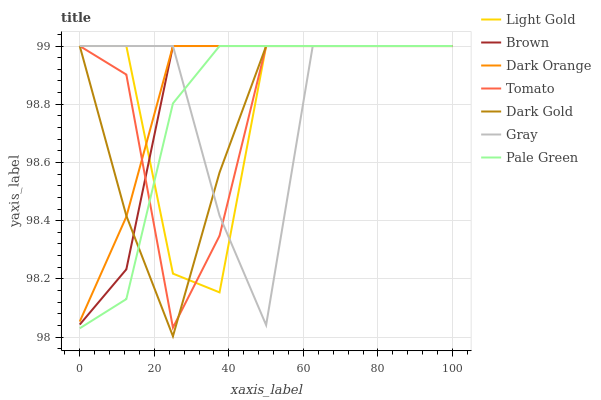Does Dark Gold have the minimum area under the curve?
Answer yes or no. Yes. Does Dark Orange have the maximum area under the curve?
Answer yes or no. Yes. Does Brown have the minimum area under the curve?
Answer yes or no. No. Does Brown have the maximum area under the curve?
Answer yes or no. No. Is Dark Orange the smoothest?
Answer yes or no. Yes. Is Light Gold the roughest?
Answer yes or no. Yes. Is Brown the smoothest?
Answer yes or no. No. Is Brown the roughest?
Answer yes or no. No. Does Dark Gold have the lowest value?
Answer yes or no. Yes. Does Brown have the lowest value?
Answer yes or no. No. Does Light Gold have the highest value?
Answer yes or no. Yes. Does Dark Gold intersect Dark Orange?
Answer yes or no. Yes. Is Dark Gold less than Dark Orange?
Answer yes or no. No. Is Dark Gold greater than Dark Orange?
Answer yes or no. No. 